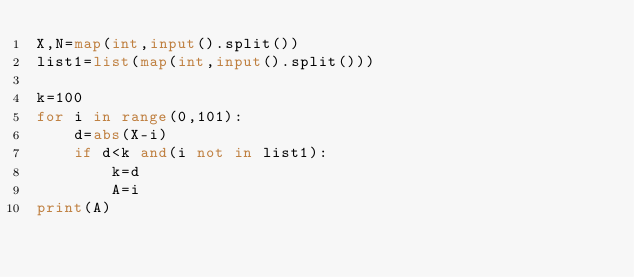<code> <loc_0><loc_0><loc_500><loc_500><_Python_>X,N=map(int,input().split())
list1=list(map(int,input().split()))

k=100
for i in range(0,101):
    d=abs(X-i)
    if d<k and(i not in list1):
        k=d
        A=i
print(A)</code> 